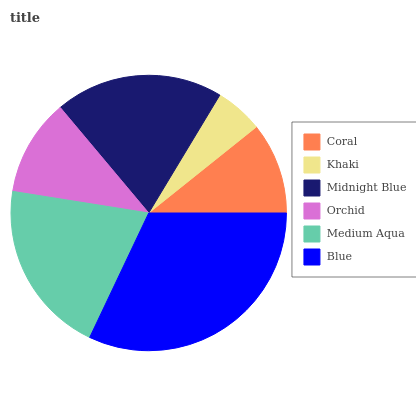Is Khaki the minimum?
Answer yes or no. Yes. Is Blue the maximum?
Answer yes or no. Yes. Is Midnight Blue the minimum?
Answer yes or no. No. Is Midnight Blue the maximum?
Answer yes or no. No. Is Midnight Blue greater than Khaki?
Answer yes or no. Yes. Is Khaki less than Midnight Blue?
Answer yes or no. Yes. Is Khaki greater than Midnight Blue?
Answer yes or no. No. Is Midnight Blue less than Khaki?
Answer yes or no. No. Is Midnight Blue the high median?
Answer yes or no. Yes. Is Orchid the low median?
Answer yes or no. Yes. Is Coral the high median?
Answer yes or no. No. Is Midnight Blue the low median?
Answer yes or no. No. 